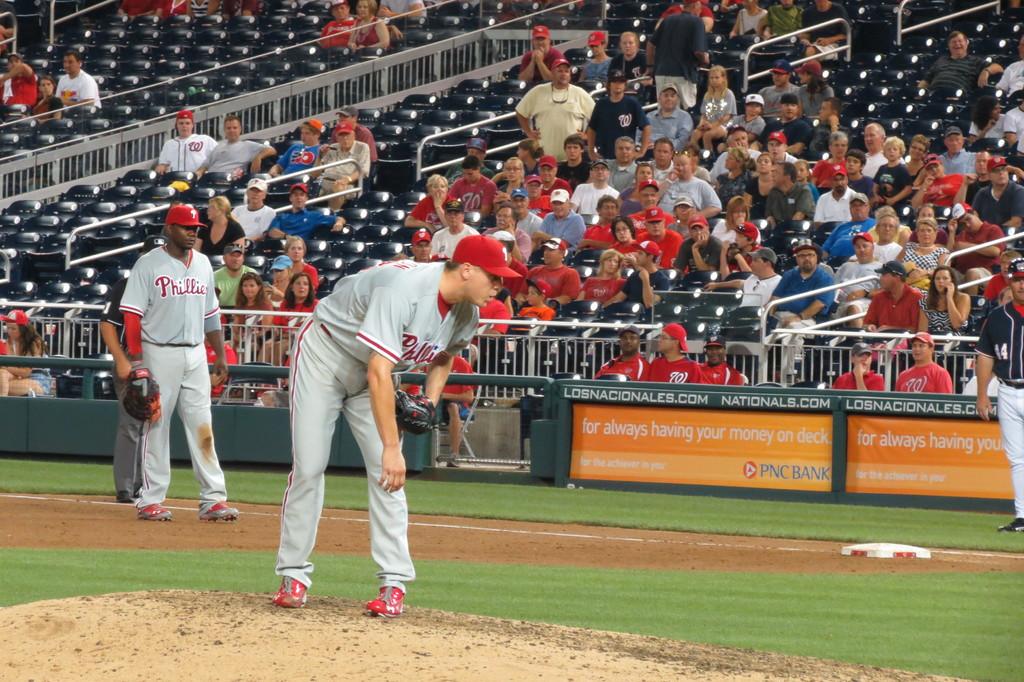What team is currently playing defense?
Your response must be concise. Phillies. 